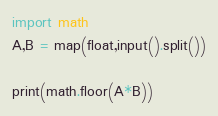<code> <loc_0><loc_0><loc_500><loc_500><_Python_>import math
A,B = map(float,input().split())

print(math.floor(A*B))
</code> 